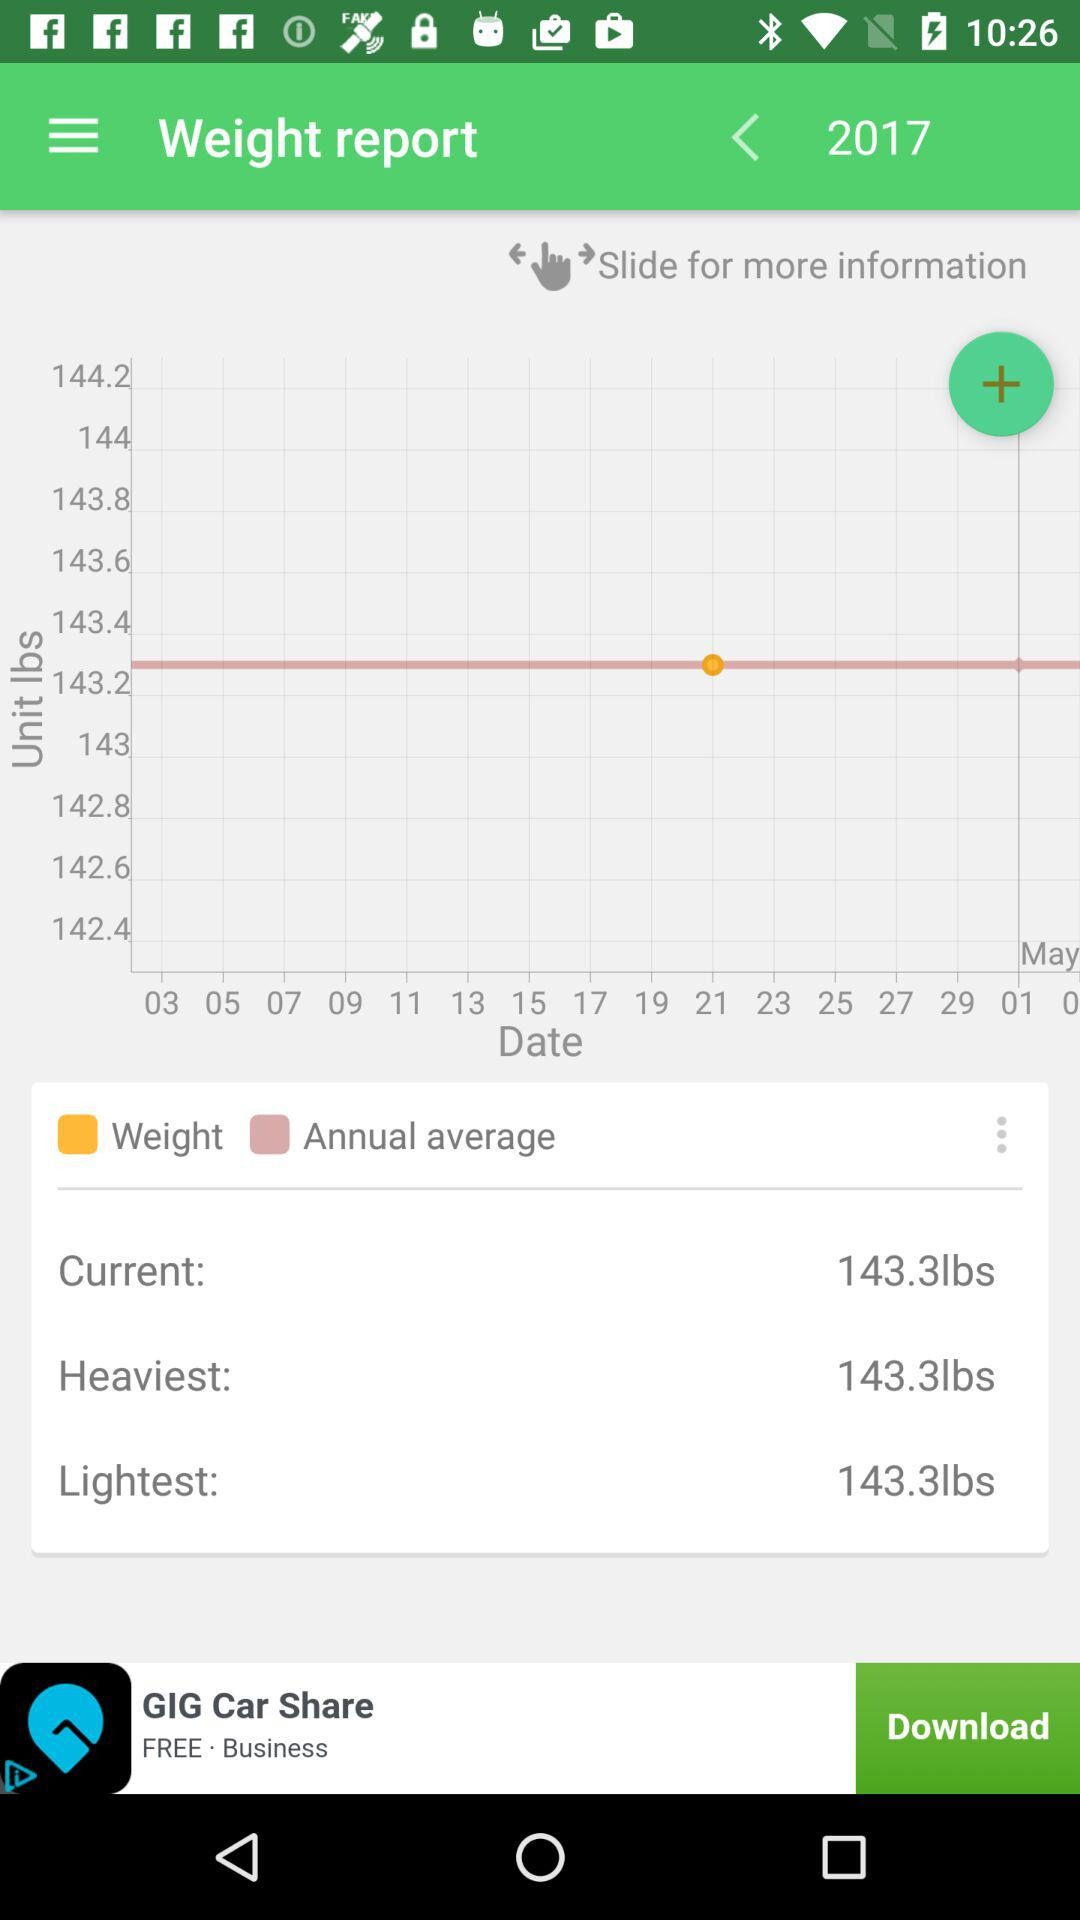What is the heaviest weight in the weight report? The heaviest weight is 143.3 lbs. 